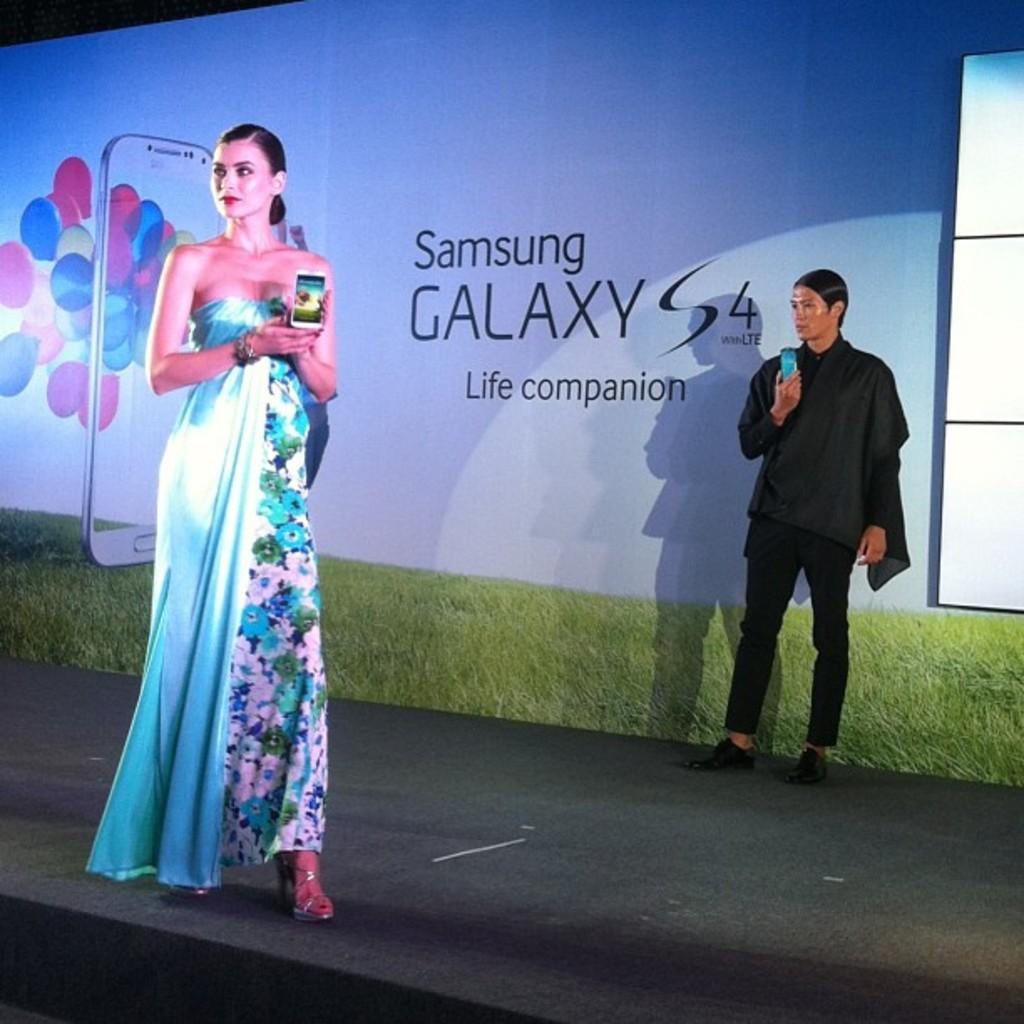Could you give a brief overview of what you see in this image? In this picture there is a woman wearing blue dress is standing and holding a mobile phone in her hand and there is another person wearing black dress is standing and holding a mobile phone in his hand behind her and there is a banner behind them which has Samsung galaxy s4 written on it. 